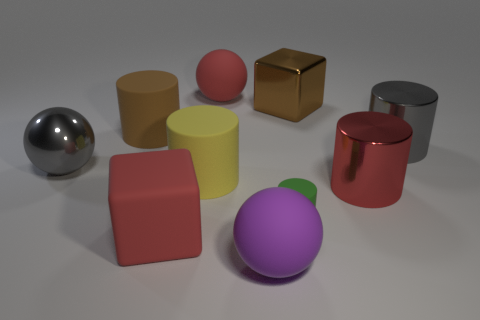Subtract all red cylinders. How many cylinders are left? 4 Subtract all red cylinders. How many cylinders are left? 4 Subtract all blocks. How many objects are left? 8 Subtract 2 balls. How many balls are left? 1 Subtract all gray cubes. Subtract all yellow balls. How many cubes are left? 2 Subtract all small green rubber cylinders. Subtract all large purple matte balls. How many objects are left? 8 Add 4 small green rubber things. How many small green rubber things are left? 5 Add 6 brown matte things. How many brown matte things exist? 7 Subtract 0 purple cylinders. How many objects are left? 10 